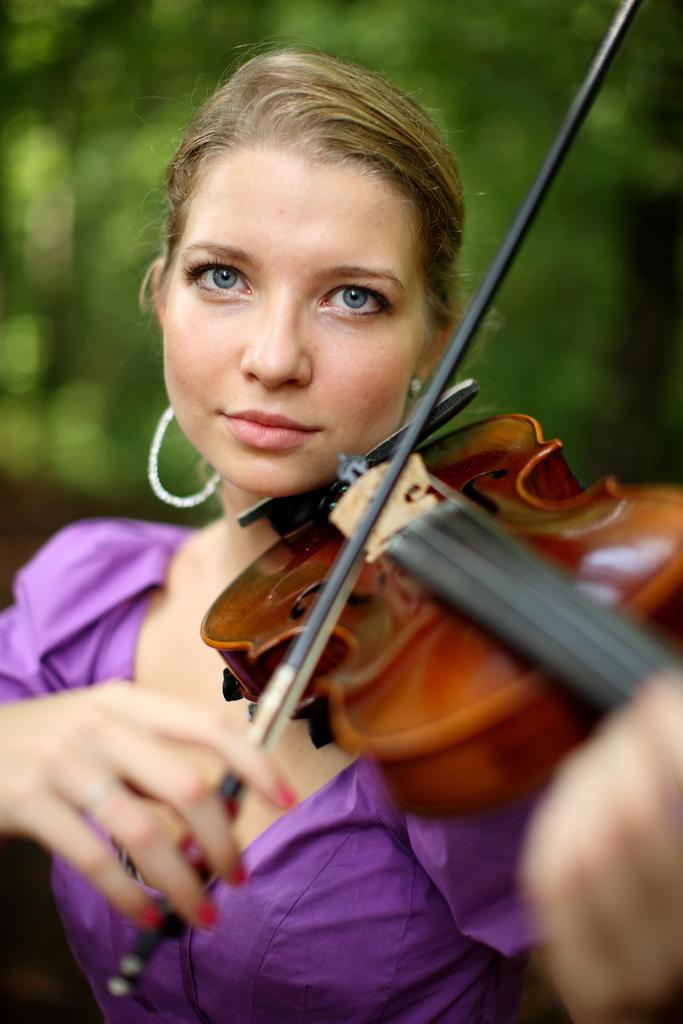What is the woman in the image doing? The woman is playing a violin in the image. What can be seen in the background of the image? There is a tree in the background of the image. How would you describe the background of the image? The background of the image is blurry. How many crates are stacked next to the woman in the image? There are no crates present in the image. What is the temperature of the hot beverage the woman is holding in the image? The woman is not holding a hot beverage in the image; she is playing a violin. 